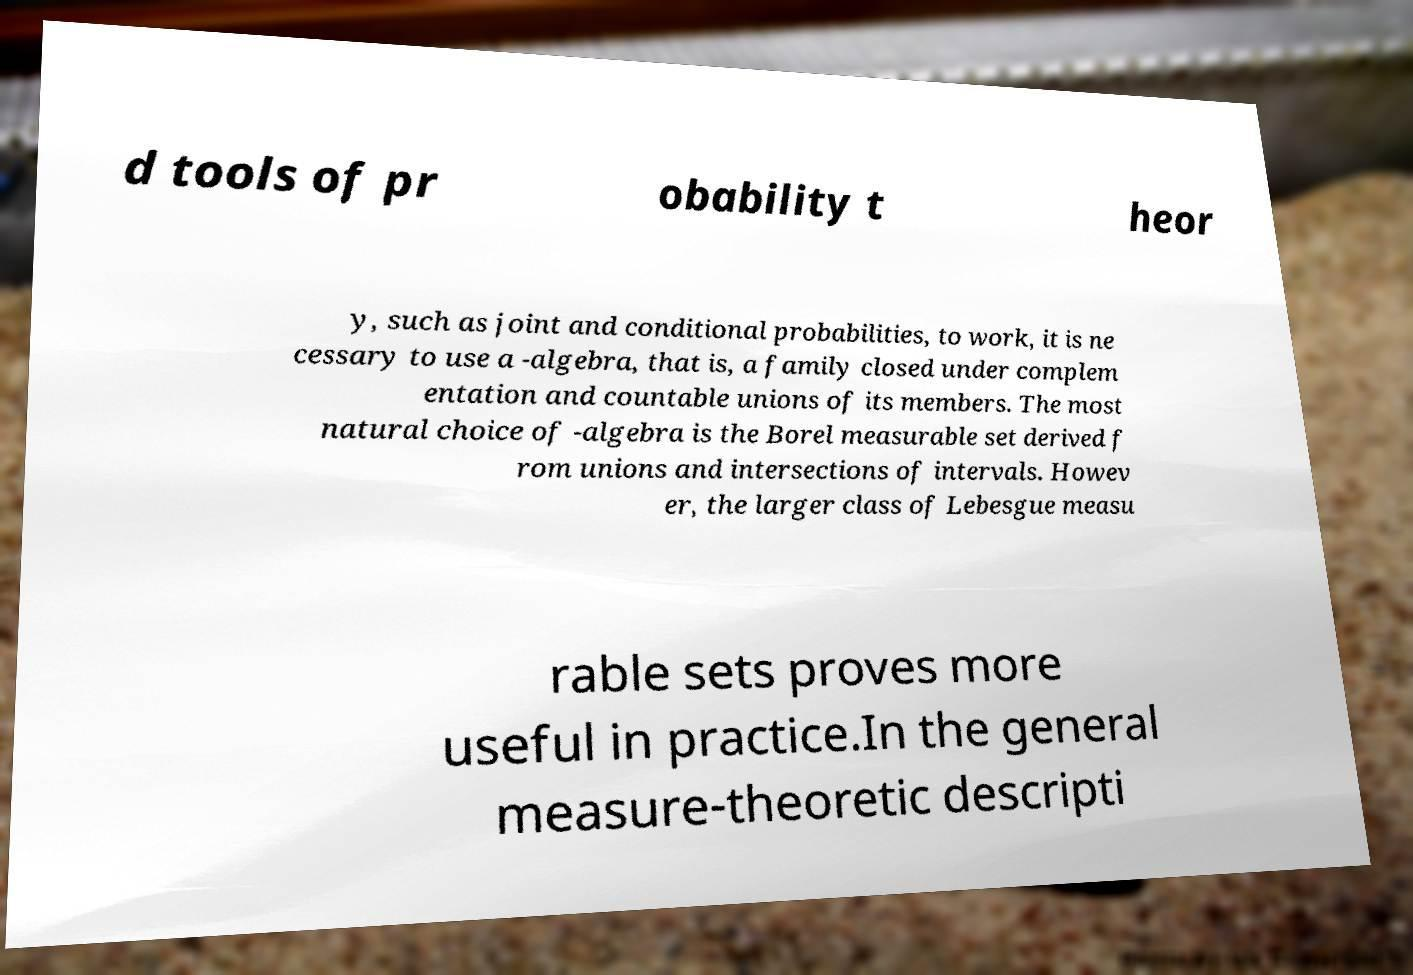Please read and relay the text visible in this image. What does it say? d tools of pr obability t heor y, such as joint and conditional probabilities, to work, it is ne cessary to use a -algebra, that is, a family closed under complem entation and countable unions of its members. The most natural choice of -algebra is the Borel measurable set derived f rom unions and intersections of intervals. Howev er, the larger class of Lebesgue measu rable sets proves more useful in practice.In the general measure-theoretic descripti 